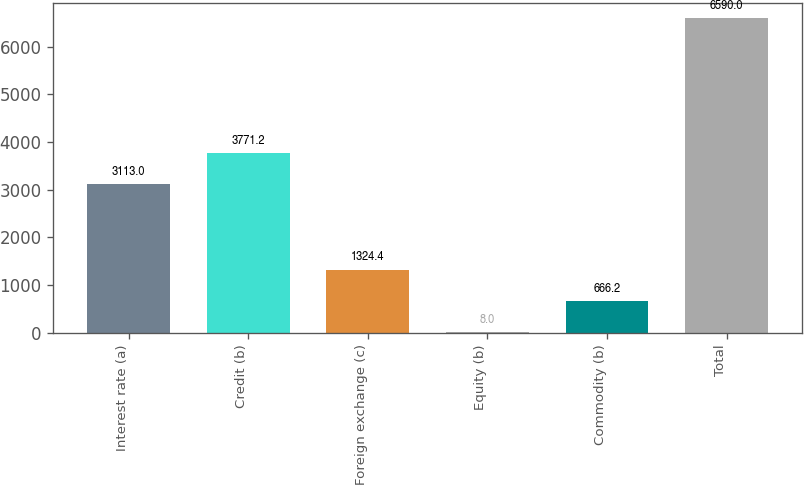Convert chart to OTSL. <chart><loc_0><loc_0><loc_500><loc_500><bar_chart><fcel>Interest rate (a)<fcel>Credit (b)<fcel>Foreign exchange (c)<fcel>Equity (b)<fcel>Commodity (b)<fcel>Total<nl><fcel>3113<fcel>3771.2<fcel>1324.4<fcel>8<fcel>666.2<fcel>6590<nl></chart> 